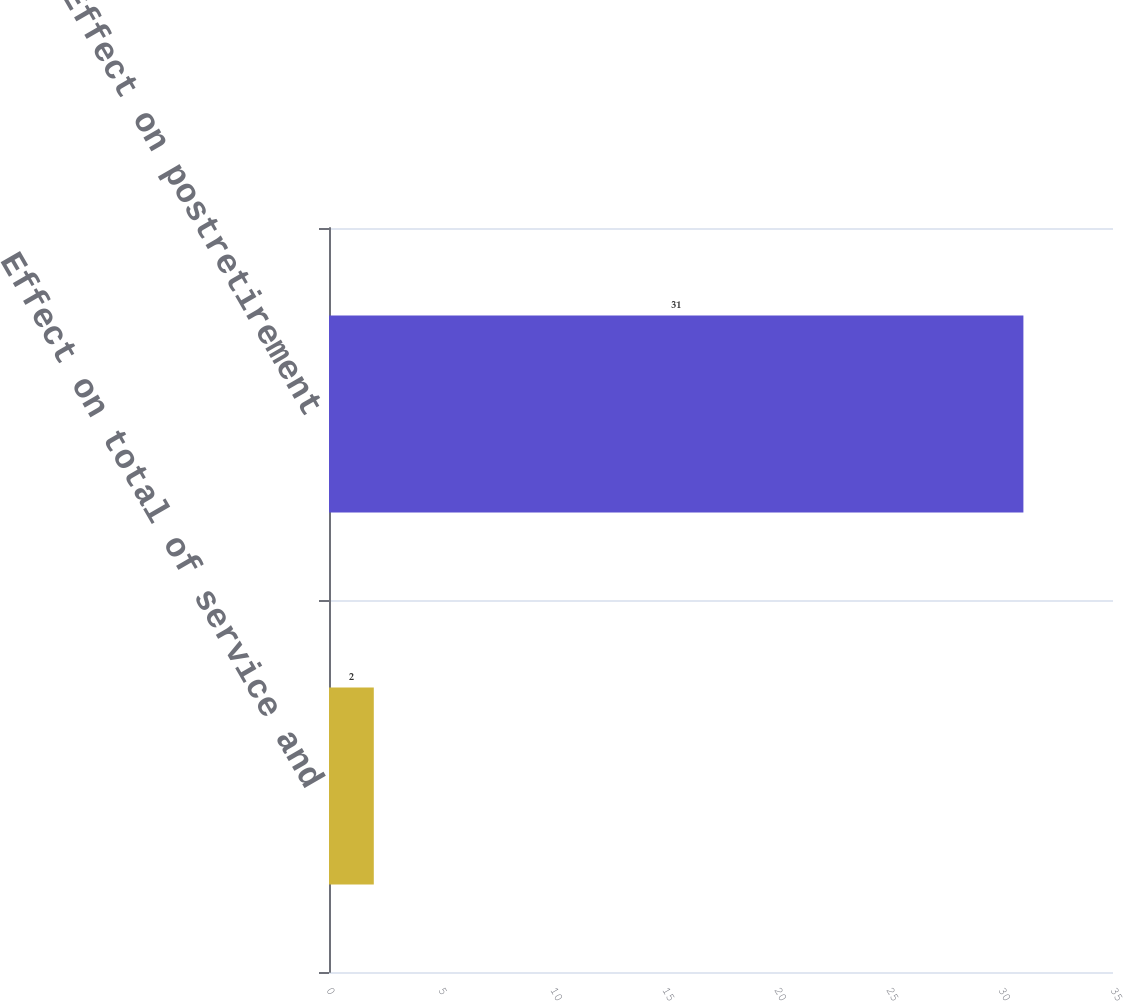Convert chart. <chart><loc_0><loc_0><loc_500><loc_500><bar_chart><fcel>Effect on total of service and<fcel>Effect on postretirement<nl><fcel>2<fcel>31<nl></chart> 